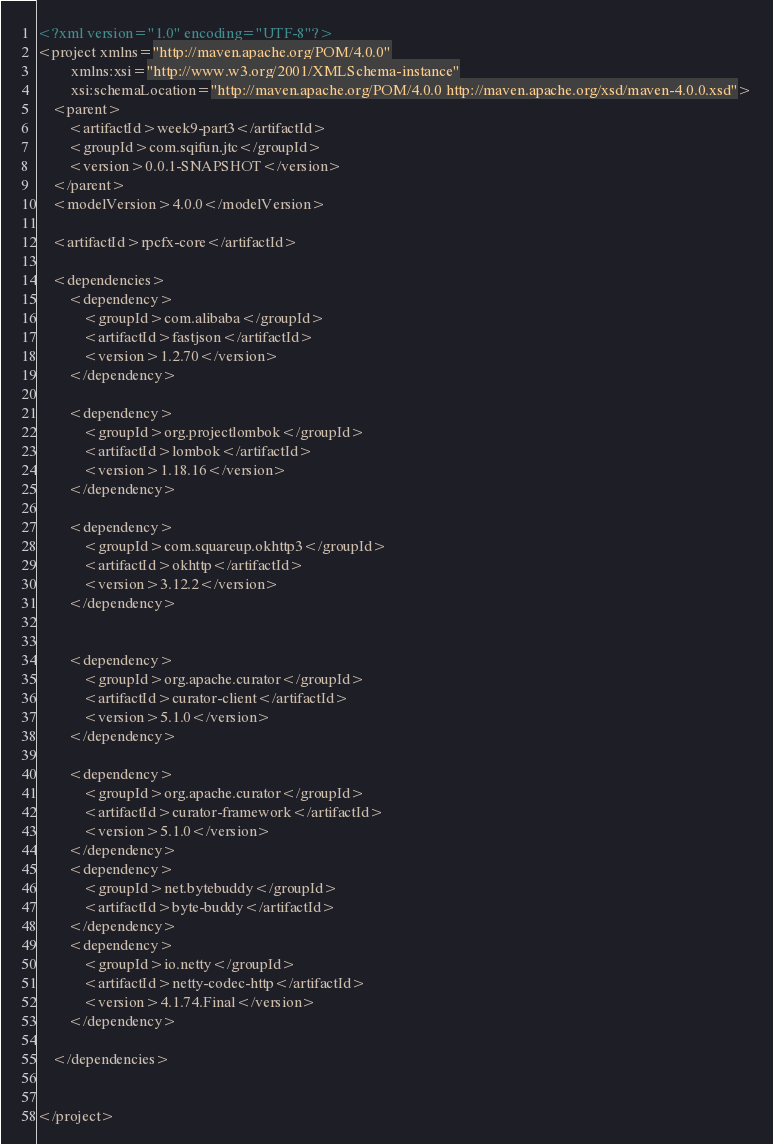Convert code to text. <code><loc_0><loc_0><loc_500><loc_500><_XML_><?xml version="1.0" encoding="UTF-8"?>
<project xmlns="http://maven.apache.org/POM/4.0.0"
         xmlns:xsi="http://www.w3.org/2001/XMLSchema-instance"
         xsi:schemaLocation="http://maven.apache.org/POM/4.0.0 http://maven.apache.org/xsd/maven-4.0.0.xsd">
    <parent>
        <artifactId>week9-part3</artifactId>
        <groupId>com.sqifun.jtc</groupId>
        <version>0.0.1-SNAPSHOT</version>
    </parent>
    <modelVersion>4.0.0</modelVersion>

    <artifactId>rpcfx-core</artifactId>

    <dependencies>
        <dependency>
            <groupId>com.alibaba</groupId>
            <artifactId>fastjson</artifactId>
            <version>1.2.70</version>
        </dependency>

        <dependency>
            <groupId>org.projectlombok</groupId>
            <artifactId>lombok</artifactId>
            <version>1.18.16</version>
        </dependency>

        <dependency>
            <groupId>com.squareup.okhttp3</groupId>
            <artifactId>okhttp</artifactId>
            <version>3.12.2</version>
        </dependency>


        <dependency>
            <groupId>org.apache.curator</groupId>
            <artifactId>curator-client</artifactId>
            <version>5.1.0</version>
        </dependency>

        <dependency>
            <groupId>org.apache.curator</groupId>
            <artifactId>curator-framework</artifactId>
            <version>5.1.0</version>
        </dependency>
        <dependency>
            <groupId>net.bytebuddy</groupId>
            <artifactId>byte-buddy</artifactId>
        </dependency>
        <dependency>
            <groupId>io.netty</groupId>
            <artifactId>netty-codec-http</artifactId>
            <version>4.1.74.Final</version>
        </dependency>

    </dependencies>


</project></code> 